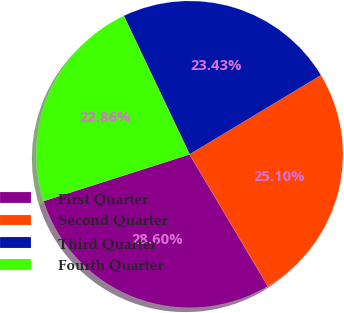Convert chart. <chart><loc_0><loc_0><loc_500><loc_500><pie_chart><fcel>First Quarter<fcel>Second Quarter<fcel>Third Quarter<fcel>Fourth Quarter<nl><fcel>28.6%<fcel>25.1%<fcel>23.43%<fcel>22.86%<nl></chart> 